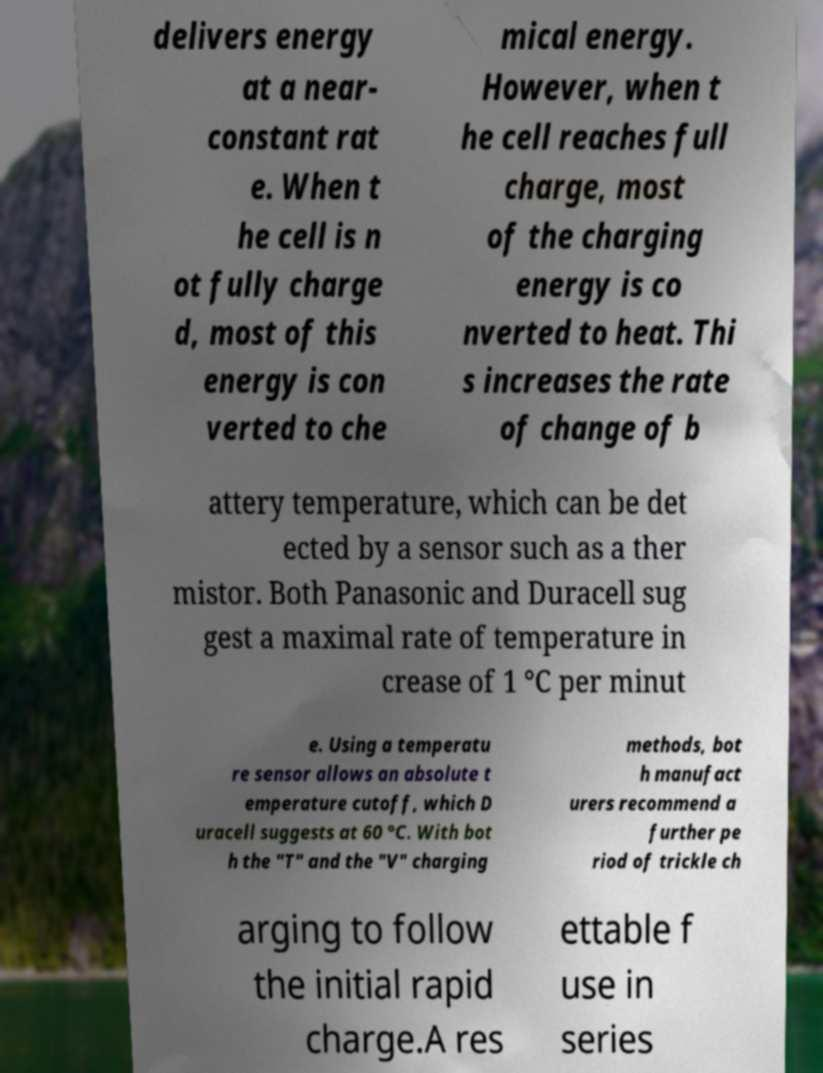Can you read and provide the text displayed in the image?This photo seems to have some interesting text. Can you extract and type it out for me? delivers energy at a near- constant rat e. When t he cell is n ot fully charge d, most of this energy is con verted to che mical energy. However, when t he cell reaches full charge, most of the charging energy is co nverted to heat. Thi s increases the rate of change of b attery temperature, which can be det ected by a sensor such as a ther mistor. Both Panasonic and Duracell sug gest a maximal rate of temperature in crease of 1 °C per minut e. Using a temperatu re sensor allows an absolute t emperature cutoff, which D uracell suggests at 60 °C. With bot h the "T" and the "V" charging methods, bot h manufact urers recommend a further pe riod of trickle ch arging to follow the initial rapid charge.A res ettable f use in series 